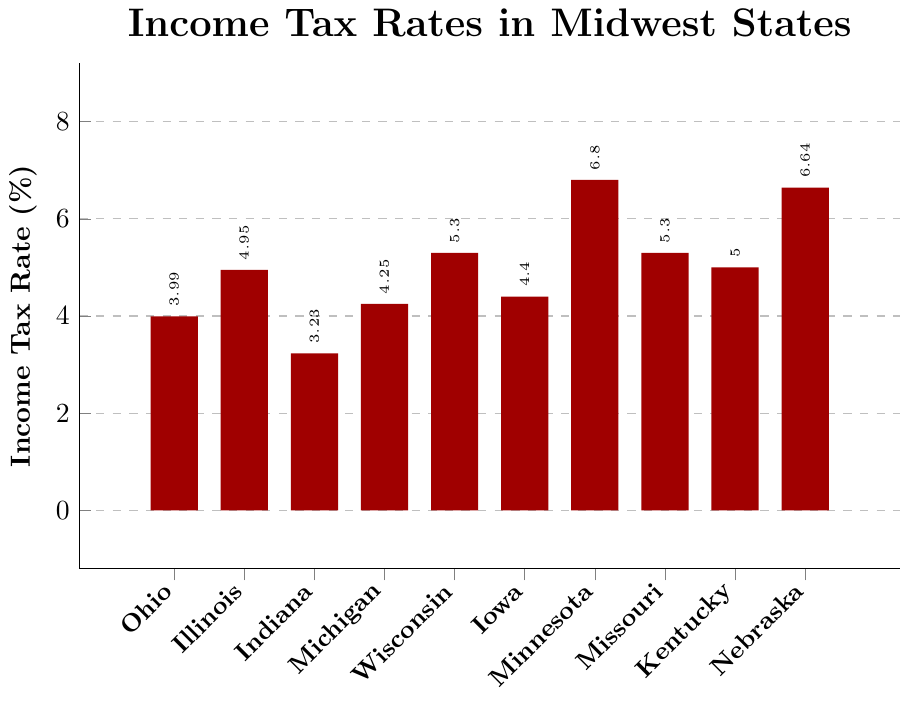Which state has the highest income tax rate? By observing the height of the bars, Minnesota has the tallest bar, indicating the highest income tax rate.
Answer: Minnesota What is the income tax rate difference between Nebraska and Ohio? By comparing the heights of the bars for Nebraska and Ohio, Nebraska's rate is 6.64% and Ohio's is 3.99%. Subtracting these values will give: 6.64 - 3.99 = 2.65
Answer: 2.65% How many states have an income tax rate higher than Ohio's? Compare each state's bar to Ohio’s bar, Ohio's rate is 3.99%. The states with rates higher than 3.99% are Illinois, Michigan, Wisconsin, Iowa, Minnesota, Missouri, Kentucky, and Nebraska (8 states).
Answer: 8 What is the average income tax rate for all listed Midwest states? Add all the tax rates and divide by the number of states. Sum = 3.99 + 4.95 + 3.23 + 4.25 + 5.30 + 4.40 + 6.80 + 5.30 + 5.00 + 6.64 = 49.86. Average = 49.86/10 = 4.986.
Answer: 4.99% Which states have an income tax rate within 0.5% of Ohio's rate? Ohio's rate is 3.99%. Thus, looking for states with rates between 3.49% and 4.49%. These states are Indiana (3.23%), Michigan (4.25%), and Iowa (4.40%).
Answer: Michigan, Iowa Which state has a lower income tax rate, Iowa or Illinois? Compare the height of the bars for Iowa and Illinois. Iowa's rate is 4.40% and Illinois's is 4.95%.
Answer: Iowa How much more is Minnesota's tax rate compared to Indiana's? Minnesota's rate is 6.80% and Indiana's is 3.23%. Subtracting 3.23 from 6.80 gives 6.80 - 3.23 = 3.57.
Answer: 3.57% What is the median income tax rate among these states? Organize the rates in ascending order: 3.23, 3.99, 4.25, 4.40, 4.95, 5.00, 5.30, 5.30, 6.64, 6.80. The median value falls between the 5th and 6th values in this list: (4.95 + 5.00)/2 = 4.975.
Answer: 4.98% Which state has a tax rate closest to 5%? The tax rate closest to 5% is visually identified by comparing the heights of the bars around 5%. Kentucky has exactly a 5% income tax rate.
Answer: Kentucky Identify all states with income tax rates above 5%. Illinois, Wisconsin, Minnesota, Missouri, and Nebraska have bars that cross the 5% mark.
Answer: Illinois, Wisconsin, Minnesota, Missouri, Nebraska 